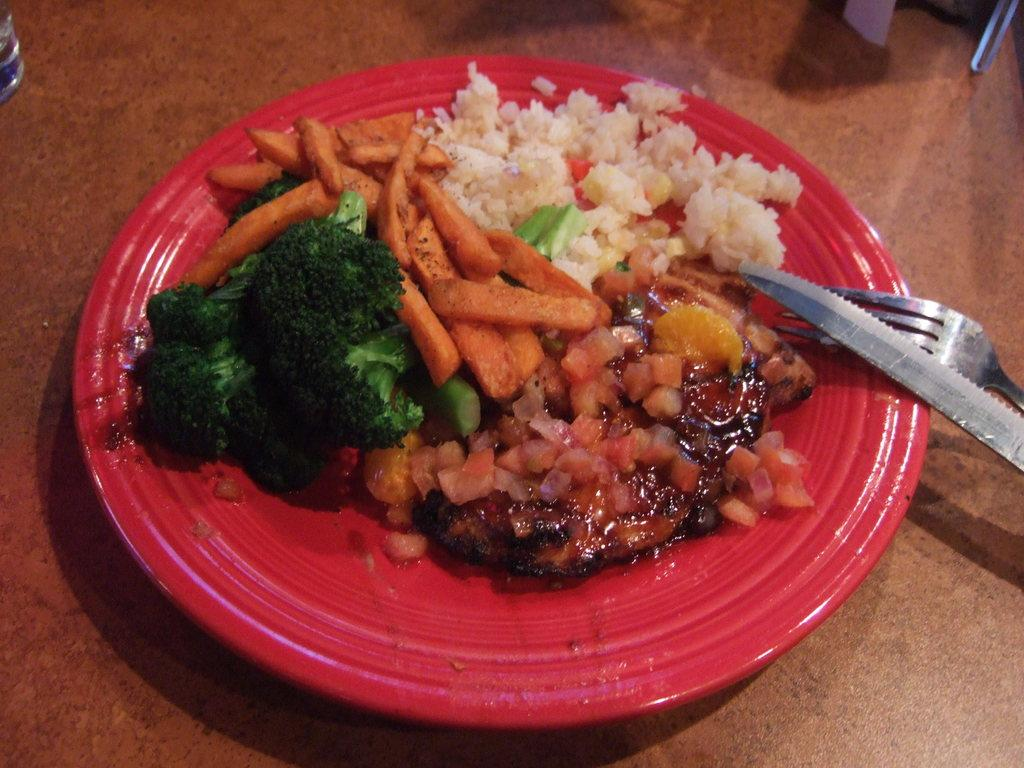What is the food item on the plate in the image? The specific food item is not mentioned in the facts, but there is a food item on a plate in the image. What utensils are visible in the image? There is a fork and a knife on the right side of the image. How are the utensils positioned in relation to the food item? The fork and knife are on the right side of the image, which suggests they might be used to eat the food item on the plate. What type of plant or twig is growing on the fork in the image? There is no plant or twig growing on the fork in the image; it is a utensil used for eating. 